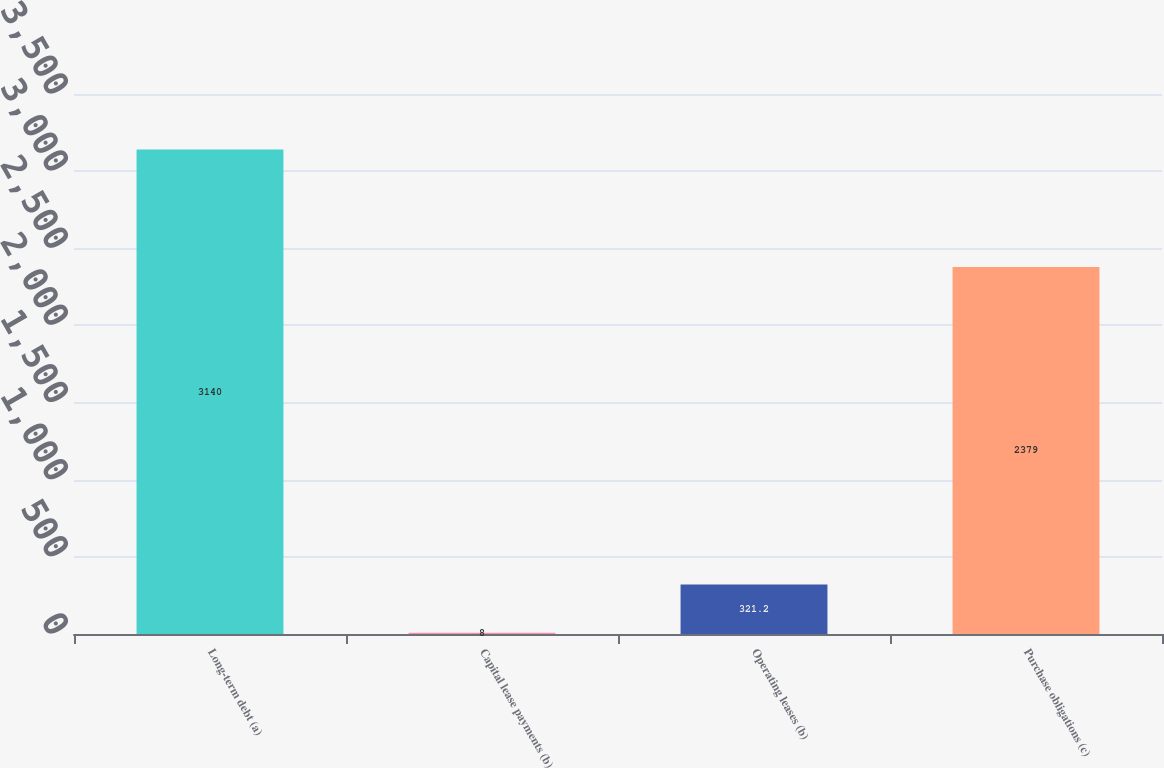Convert chart. <chart><loc_0><loc_0><loc_500><loc_500><bar_chart><fcel>Long-term debt (a)<fcel>Capital lease payments (b)<fcel>Operating leases (b)<fcel>Purchase obligations (c)<nl><fcel>3140<fcel>8<fcel>321.2<fcel>2379<nl></chart> 